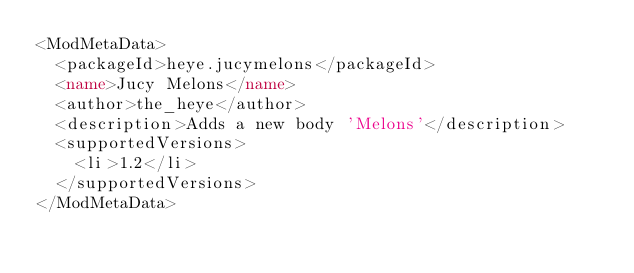<code> <loc_0><loc_0><loc_500><loc_500><_XML_><ModMetaData>
  <packageId>heye.jucymelons</packageId>
  <name>Jucy Melons</name>
  <author>the_heye</author>
  <description>Adds a new body 'Melons'</description>
  <supportedVersions>
    <li>1.2</li>
  </supportedVersions>
</ModMetaData>
</code> 